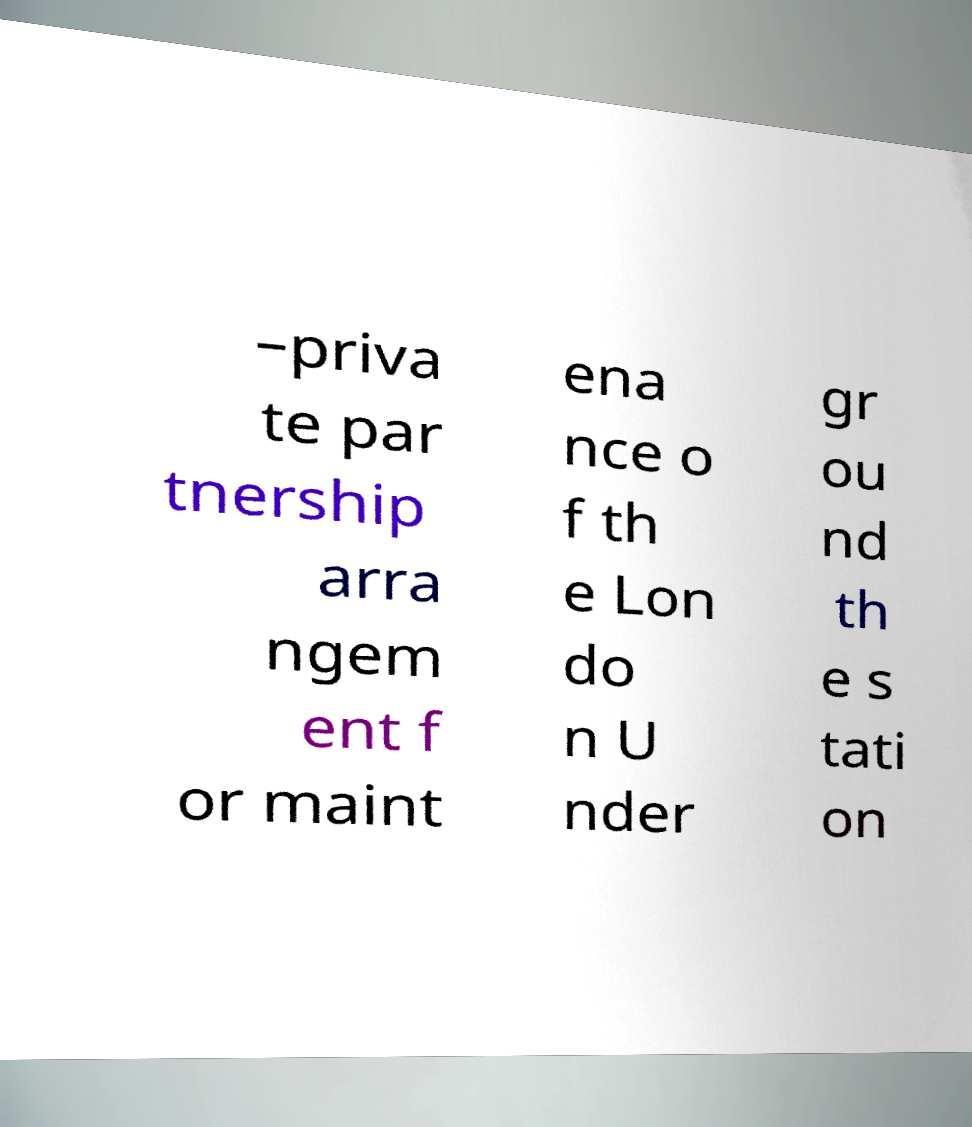What messages or text are displayed in this image? I need them in a readable, typed format. –priva te par tnership arra ngem ent f or maint ena nce o f th e Lon do n U nder gr ou nd th e s tati on 